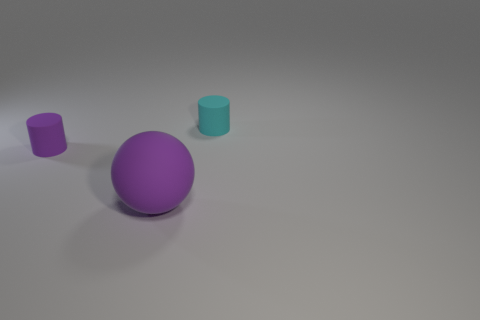What number of large purple rubber balls are behind the small cyan rubber object?
Give a very brief answer. 0. There is a small object that is behind the tiny matte cylinder that is in front of the cyan rubber thing; what is its material?
Ensure brevity in your answer.  Rubber. There is a purple object that is the same size as the cyan object; what is it made of?
Provide a succinct answer. Rubber. Are there any purple matte balls of the same size as the cyan thing?
Your answer should be very brief. No. The tiny cylinder that is on the right side of the matte ball is what color?
Keep it short and to the point. Cyan. Are there any cylinders in front of the tiny matte thing that is on the right side of the tiny purple rubber cylinder?
Your answer should be compact. Yes. How many other objects are there of the same color as the ball?
Provide a succinct answer. 1. There is a cylinder that is behind the tiny purple matte cylinder; is it the same size as the rubber cylinder in front of the cyan matte cylinder?
Offer a terse response. Yes. What size is the purple matte thing to the right of the matte cylinder that is in front of the small cyan cylinder?
Make the answer very short. Large. What material is the thing that is both behind the purple matte sphere and in front of the cyan matte object?
Ensure brevity in your answer.  Rubber. 